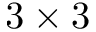Convert formula to latex. <formula><loc_0><loc_0><loc_500><loc_500>3 \times 3</formula> 